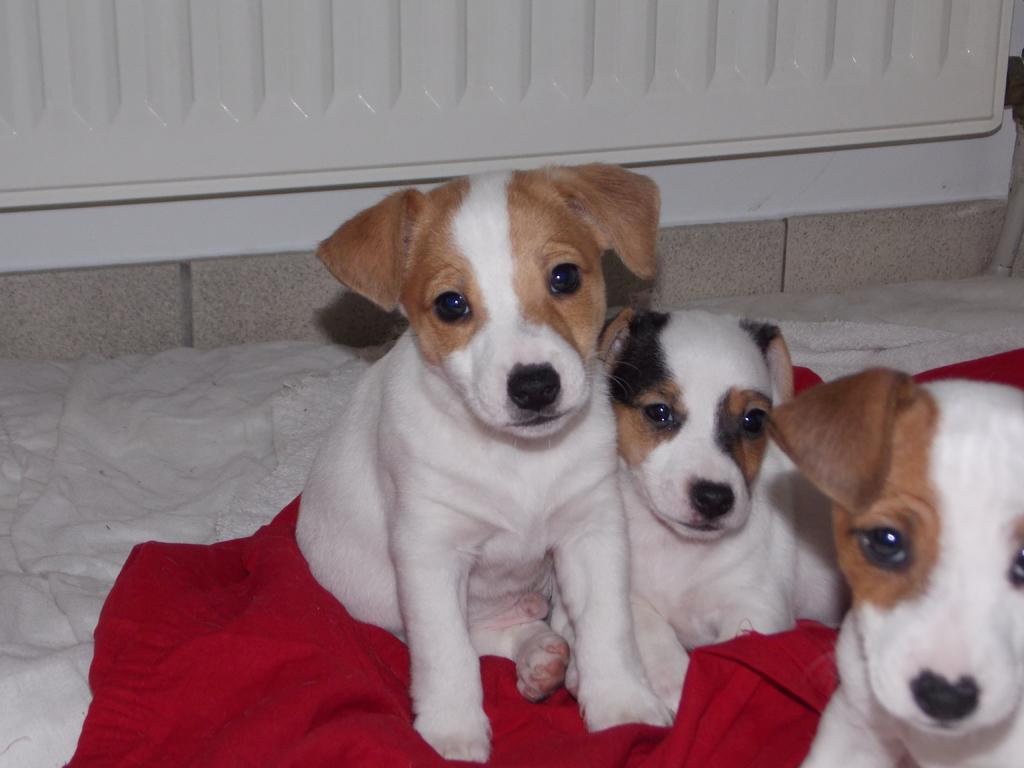What type of living organisms are present in the image? There are animals in the image. Can you describe the color patterns of the animals? The animals have white, brown, and black colors. What is the surface on which the animals are placed? The animals are on a red and white color cloth. How would you describe the background of the image? The background of the image is white and ash colored. What type of stamp can be seen on the animals in the image? There is no stamp present on the animals in the image. What scientific experiment is being conducted with the animals in the image? There is no scientific experiment depicted in the image. 